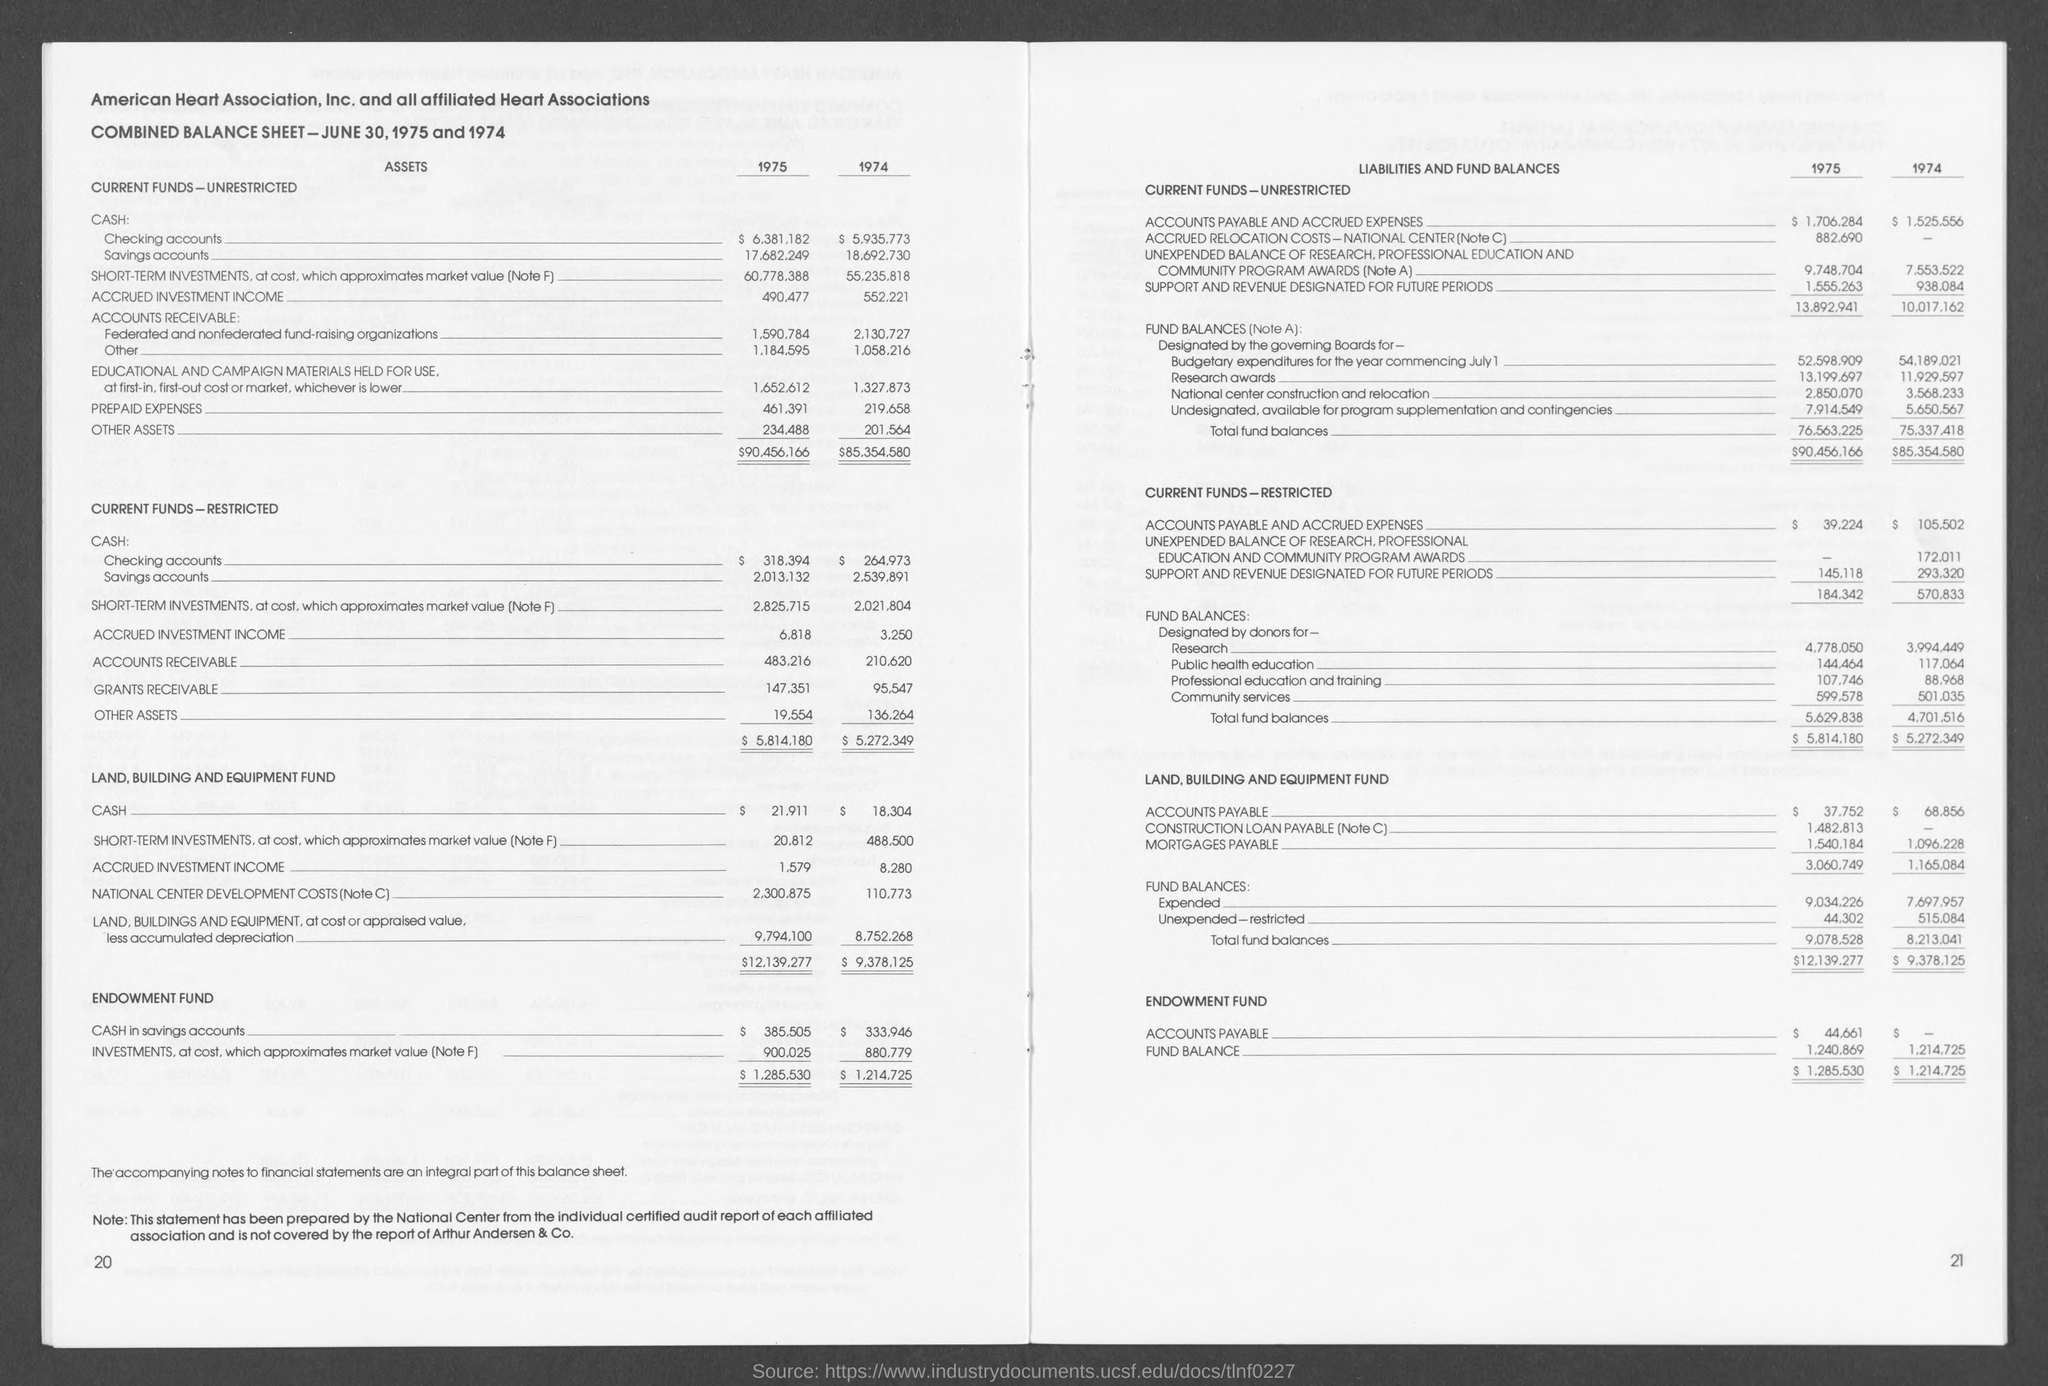Draw attention to some important aspects in this diagram. The amount for public health education in 1975, as mentioned on the given page, was 144,464. The amount for research in fund balances in 1974, as mentioned on the given page, was $3,994.449. 